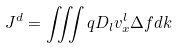<formula> <loc_0><loc_0><loc_500><loc_500>J ^ { d } = \iiint q D _ { l } v ^ { l } _ { x } \Delta f d k</formula> 